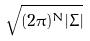<formula> <loc_0><loc_0><loc_500><loc_500>\sqrt { ( 2 \pi ) ^ { N } | \Sigma | }</formula> 